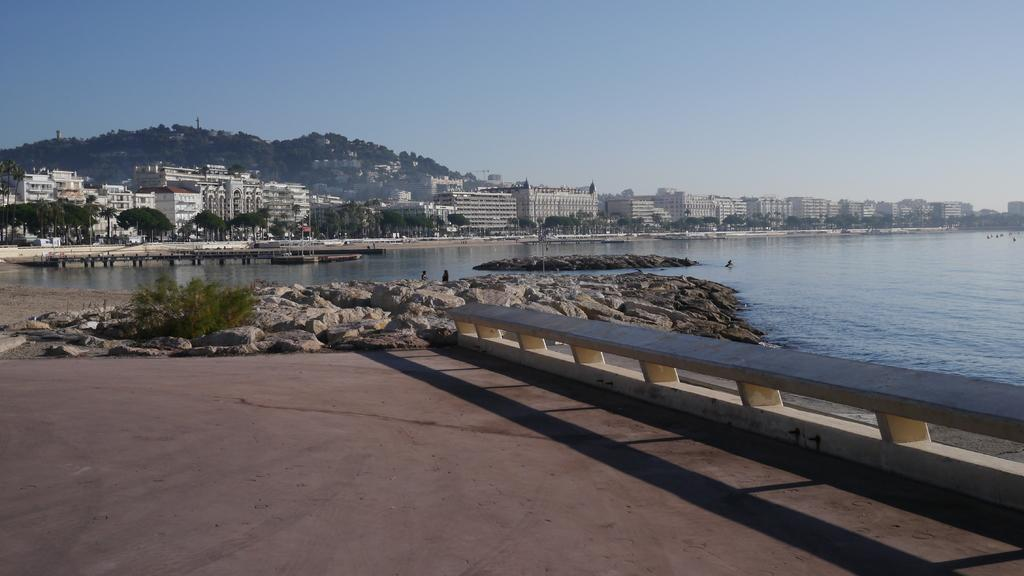What type of structures can be seen in the image? There are buildings in the image. What type of vegetation is present in the image? There are trees in the image. What natural element is visible in the image? There is water visible in the image. What is located on the right side of the image? There is a fence on the right side of the image. What can be seen in the background of the image? There is a hill and the sky visible in the background of the image. What type of wine is being served at the picnic in the image? There is no picnic or wine present in the image; it features buildings, trees, water, a fence, a hill, and the sky. 